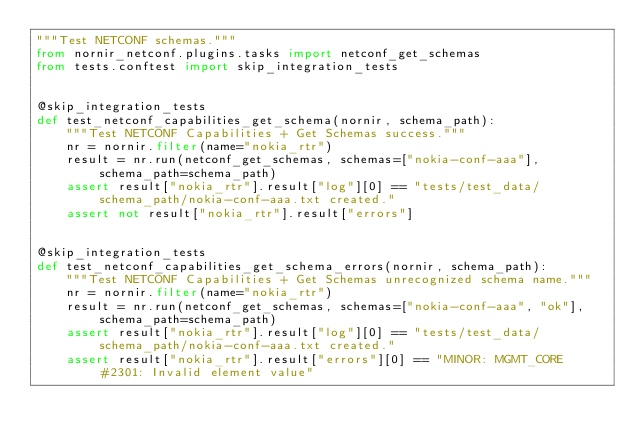Convert code to text. <code><loc_0><loc_0><loc_500><loc_500><_Python_>"""Test NETCONF schemas."""
from nornir_netconf.plugins.tasks import netconf_get_schemas
from tests.conftest import skip_integration_tests


@skip_integration_tests
def test_netconf_capabilities_get_schema(nornir, schema_path):
    """Test NETCONF Capabilities + Get Schemas success."""
    nr = nornir.filter(name="nokia_rtr")
    result = nr.run(netconf_get_schemas, schemas=["nokia-conf-aaa"], schema_path=schema_path)
    assert result["nokia_rtr"].result["log"][0] == "tests/test_data/schema_path/nokia-conf-aaa.txt created."
    assert not result["nokia_rtr"].result["errors"]


@skip_integration_tests
def test_netconf_capabilities_get_schema_errors(nornir, schema_path):
    """Test NETCONF Capabilities + Get Schemas unrecognized schema name."""
    nr = nornir.filter(name="nokia_rtr")
    result = nr.run(netconf_get_schemas, schemas=["nokia-conf-aaa", "ok"], schema_path=schema_path)
    assert result["nokia_rtr"].result["log"][0] == "tests/test_data/schema_path/nokia-conf-aaa.txt created."
    assert result["nokia_rtr"].result["errors"][0] == "MINOR: MGMT_CORE #2301: Invalid element value"
</code> 